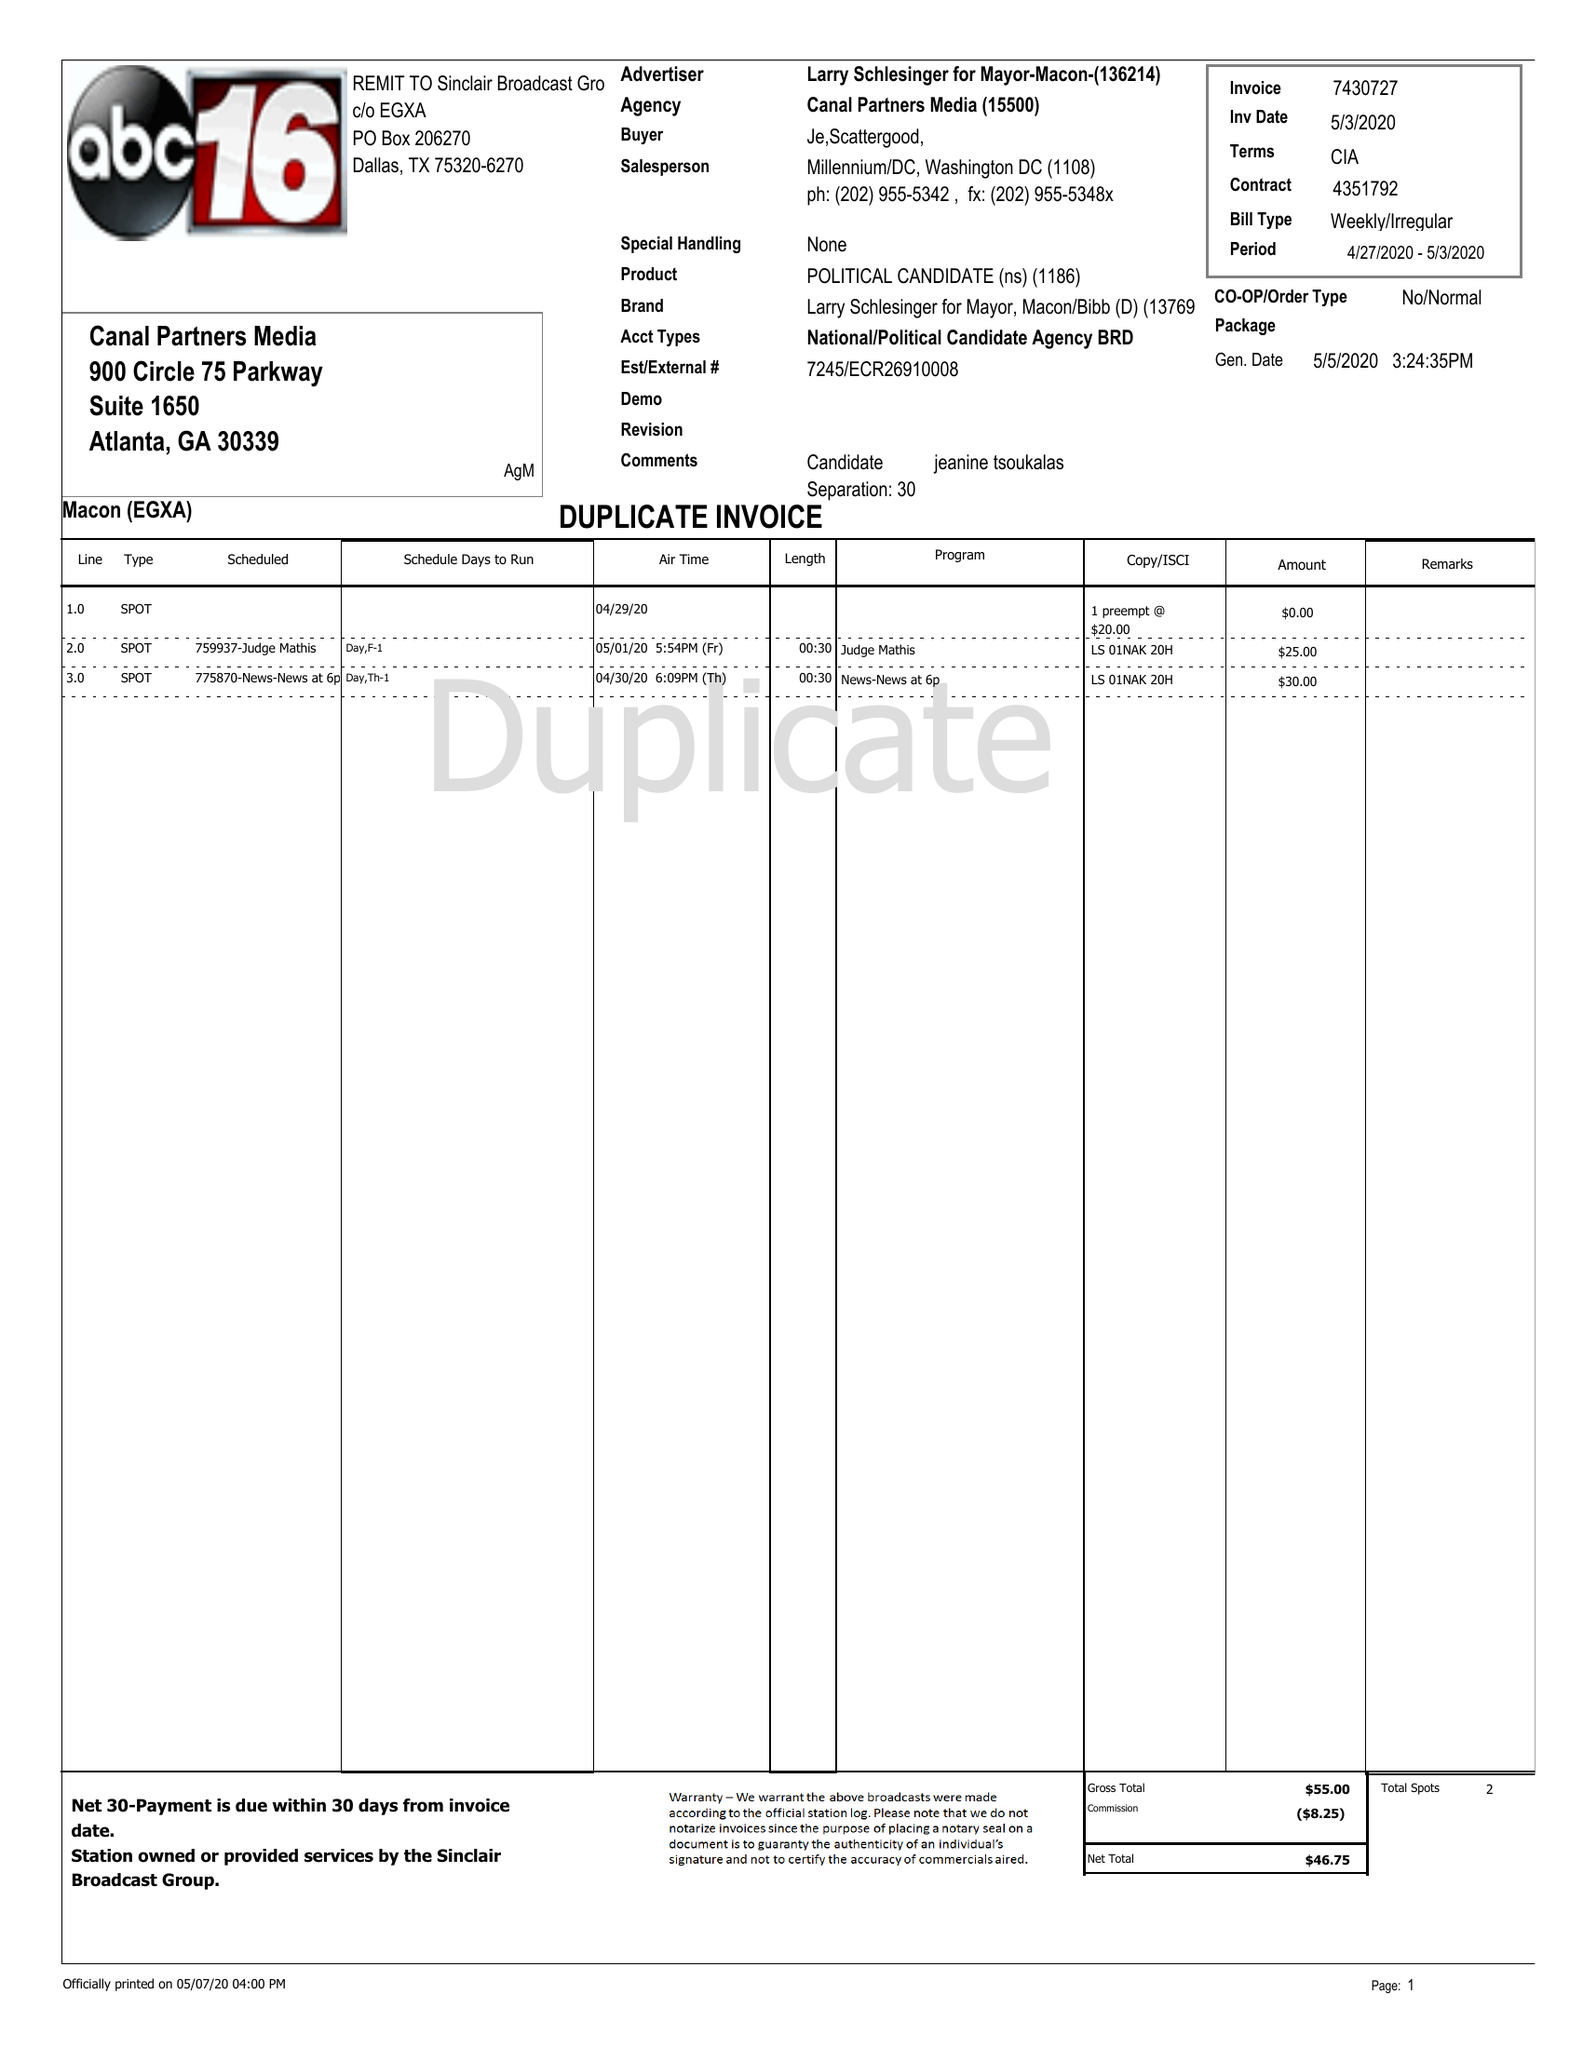What is the value for the gross_amount?
Answer the question using a single word or phrase. 55.00 